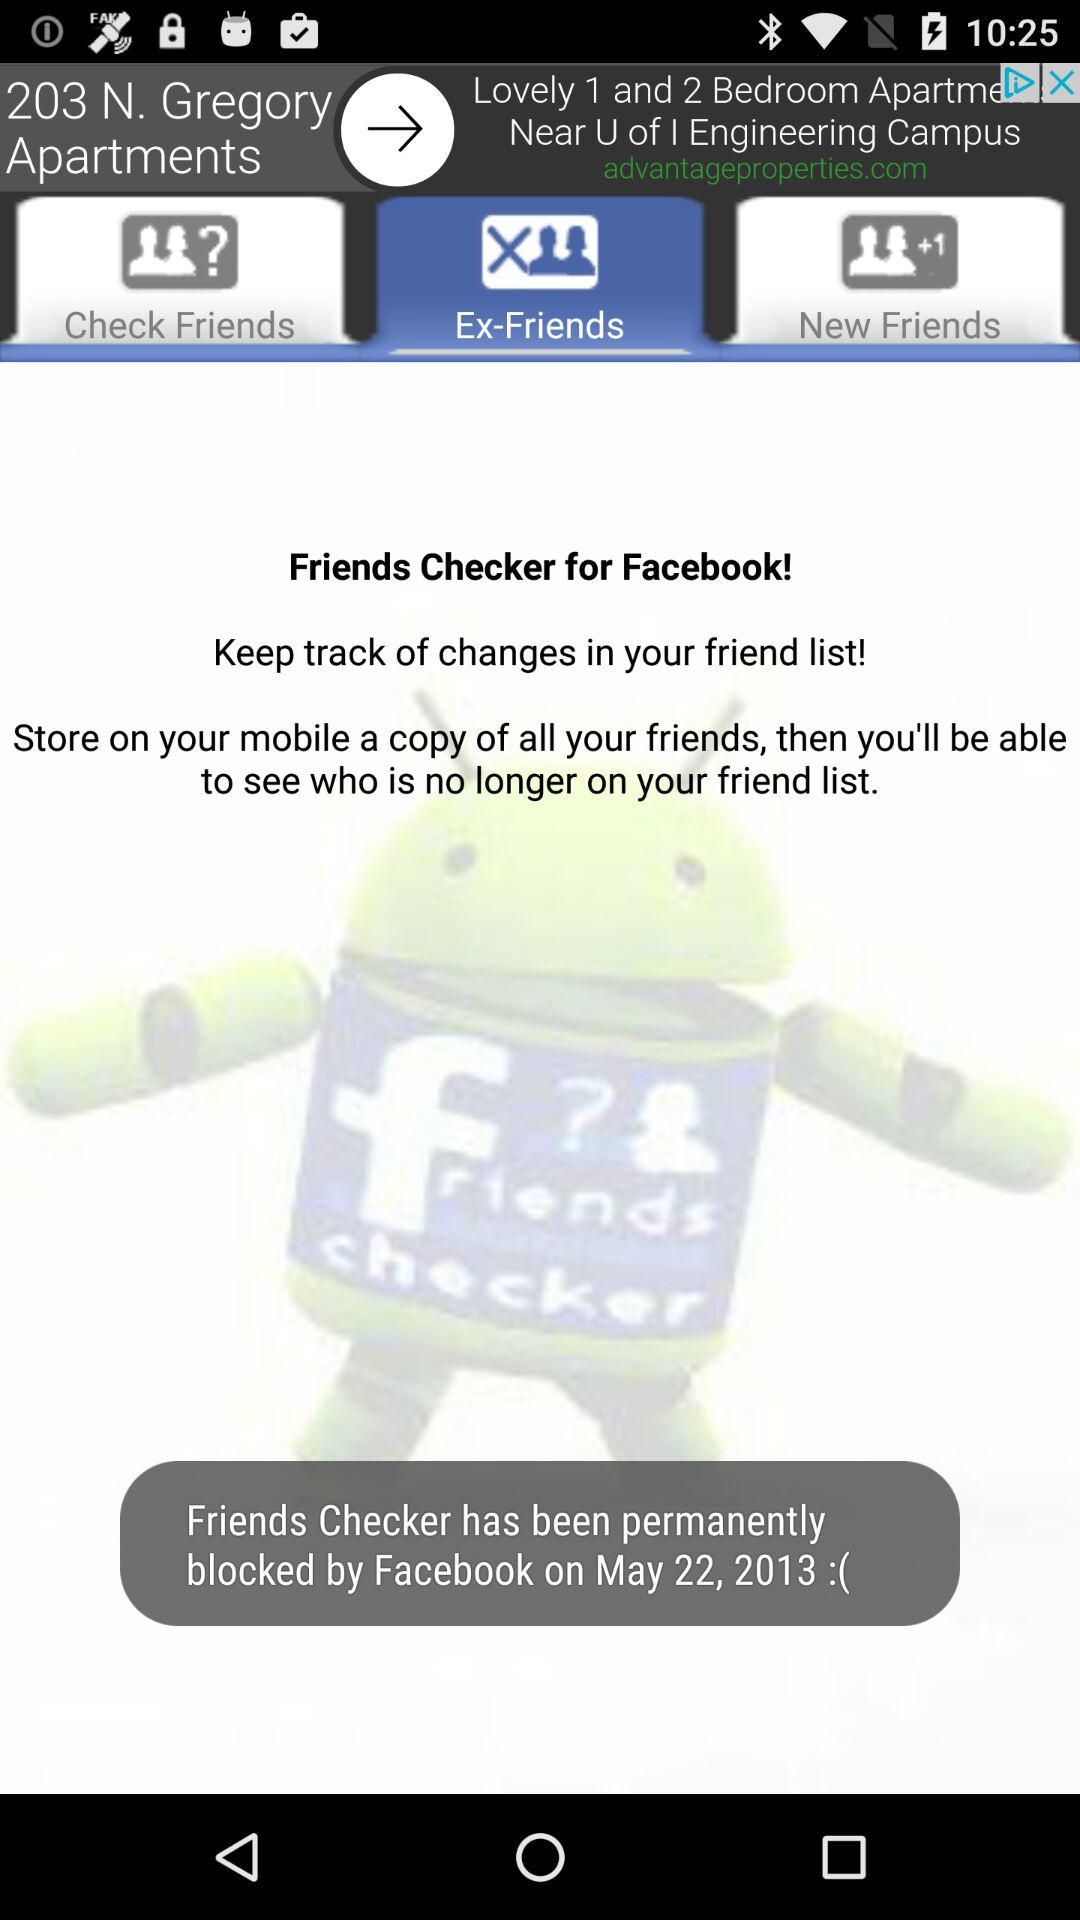Which tab is selected? The selected tab is "Ex-Friends". 